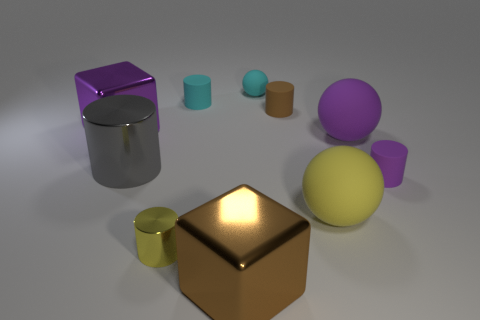There is a brown object behind the large matte object that is to the left of the purple matte sphere; are there any purple spheres that are on the left side of it?
Keep it short and to the point. No. Are there more large yellow things in front of the brown rubber cylinder than small red shiny cylinders?
Ensure brevity in your answer.  Yes. Does the tiny matte thing that is in front of the large purple metallic object have the same shape as the small brown thing?
Give a very brief answer. Yes. Is there anything else that is made of the same material as the purple cylinder?
Make the answer very short. Yes. What number of objects are either big green blocks or big cubes that are behind the small metallic cylinder?
Your response must be concise. 1. How big is the ball that is both in front of the large purple block and behind the big yellow matte ball?
Make the answer very short. Large. Are there more large objects on the left side of the gray metallic cylinder than tiny cylinders that are on the right side of the big purple matte ball?
Make the answer very short. No. Do the big purple matte thing and the yellow object that is on the right side of the yellow metallic object have the same shape?
Your answer should be compact. Yes. How many other things are the same shape as the big purple shiny object?
Give a very brief answer. 1. What is the color of the tiny cylinder that is on the right side of the cyan sphere and in front of the purple metallic object?
Make the answer very short. Purple. 